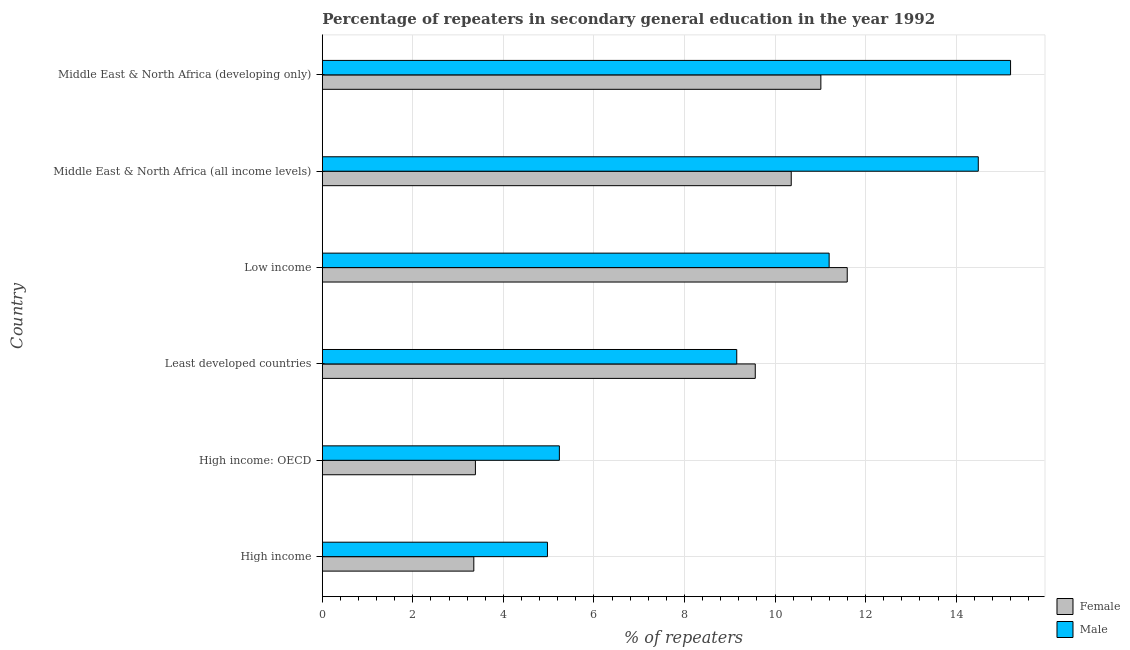How many bars are there on the 6th tick from the top?
Your answer should be very brief. 2. How many bars are there on the 6th tick from the bottom?
Provide a succinct answer. 2. What is the label of the 5th group of bars from the top?
Give a very brief answer. High income: OECD. What is the percentage of female repeaters in High income?
Your response must be concise. 3.35. Across all countries, what is the maximum percentage of female repeaters?
Your response must be concise. 11.59. Across all countries, what is the minimum percentage of female repeaters?
Provide a succinct answer. 3.35. In which country was the percentage of female repeaters maximum?
Provide a short and direct response. Low income. What is the total percentage of male repeaters in the graph?
Your answer should be compact. 60.25. What is the difference between the percentage of female repeaters in Least developed countries and that in Middle East & North Africa (developing only)?
Make the answer very short. -1.45. What is the difference between the percentage of female repeaters in High income and the percentage of male repeaters in High income: OECD?
Give a very brief answer. -1.89. What is the average percentage of male repeaters per country?
Keep it short and to the point. 10.04. What is the difference between the percentage of female repeaters and percentage of male repeaters in Middle East & North Africa (all income levels)?
Ensure brevity in your answer.  -4.13. In how many countries, is the percentage of male repeaters greater than 12 %?
Offer a very short reply. 2. What is the ratio of the percentage of female repeaters in High income: OECD to that in Least developed countries?
Provide a succinct answer. 0.35. Is the percentage of male repeaters in Least developed countries less than that in Middle East & North Africa (all income levels)?
Keep it short and to the point. Yes. What is the difference between the highest and the second highest percentage of female repeaters?
Give a very brief answer. 0.58. What is the difference between the highest and the lowest percentage of female repeaters?
Keep it short and to the point. 8.25. In how many countries, is the percentage of male repeaters greater than the average percentage of male repeaters taken over all countries?
Provide a succinct answer. 3. What does the 2nd bar from the bottom in Middle East & North Africa (all income levels) represents?
Ensure brevity in your answer.  Male. How many bars are there?
Offer a very short reply. 12. Are all the bars in the graph horizontal?
Your response must be concise. Yes. How many countries are there in the graph?
Your response must be concise. 6. What is the difference between two consecutive major ticks on the X-axis?
Offer a very short reply. 2. Are the values on the major ticks of X-axis written in scientific E-notation?
Offer a terse response. No. How many legend labels are there?
Offer a terse response. 2. What is the title of the graph?
Make the answer very short. Percentage of repeaters in secondary general education in the year 1992. Does "Under-5(male)" appear as one of the legend labels in the graph?
Provide a short and direct response. No. What is the label or title of the X-axis?
Offer a terse response. % of repeaters. What is the % of repeaters of Female in High income?
Keep it short and to the point. 3.35. What is the % of repeaters in Male in High income?
Ensure brevity in your answer.  4.97. What is the % of repeaters in Female in High income: OECD?
Provide a short and direct response. 3.38. What is the % of repeaters in Male in High income: OECD?
Your response must be concise. 5.24. What is the % of repeaters of Female in Least developed countries?
Provide a short and direct response. 9.56. What is the % of repeaters of Male in Least developed countries?
Your response must be concise. 9.15. What is the % of repeaters of Female in Low income?
Offer a very short reply. 11.59. What is the % of repeaters of Male in Low income?
Your answer should be very brief. 11.19. What is the % of repeaters of Female in Middle East & North Africa (all income levels)?
Offer a very short reply. 10.36. What is the % of repeaters of Male in Middle East & North Africa (all income levels)?
Make the answer very short. 14.49. What is the % of repeaters in Female in Middle East & North Africa (developing only)?
Give a very brief answer. 11.01. What is the % of repeaters in Male in Middle East & North Africa (developing only)?
Provide a succinct answer. 15.2. Across all countries, what is the maximum % of repeaters of Female?
Ensure brevity in your answer.  11.59. Across all countries, what is the maximum % of repeaters of Male?
Offer a very short reply. 15.2. Across all countries, what is the minimum % of repeaters of Female?
Give a very brief answer. 3.35. Across all countries, what is the minimum % of repeaters in Male?
Make the answer very short. 4.97. What is the total % of repeaters in Female in the graph?
Give a very brief answer. 49.25. What is the total % of repeaters in Male in the graph?
Make the answer very short. 60.25. What is the difference between the % of repeaters in Female in High income and that in High income: OECD?
Give a very brief answer. -0.04. What is the difference between the % of repeaters in Male in High income and that in High income: OECD?
Ensure brevity in your answer.  -0.26. What is the difference between the % of repeaters in Female in High income and that in Least developed countries?
Give a very brief answer. -6.22. What is the difference between the % of repeaters in Male in High income and that in Least developed countries?
Make the answer very short. -4.18. What is the difference between the % of repeaters of Female in High income and that in Low income?
Give a very brief answer. -8.25. What is the difference between the % of repeaters of Male in High income and that in Low income?
Provide a short and direct response. -6.22. What is the difference between the % of repeaters in Female in High income and that in Middle East & North Africa (all income levels)?
Keep it short and to the point. -7.01. What is the difference between the % of repeaters of Male in High income and that in Middle East & North Africa (all income levels)?
Your response must be concise. -9.52. What is the difference between the % of repeaters of Female in High income and that in Middle East & North Africa (developing only)?
Offer a terse response. -7.67. What is the difference between the % of repeaters of Male in High income and that in Middle East & North Africa (developing only)?
Your answer should be very brief. -10.23. What is the difference between the % of repeaters of Female in High income: OECD and that in Least developed countries?
Provide a succinct answer. -6.18. What is the difference between the % of repeaters of Male in High income: OECD and that in Least developed countries?
Give a very brief answer. -3.92. What is the difference between the % of repeaters of Female in High income: OECD and that in Low income?
Provide a succinct answer. -8.21. What is the difference between the % of repeaters in Male in High income: OECD and that in Low income?
Offer a very short reply. -5.96. What is the difference between the % of repeaters of Female in High income: OECD and that in Middle East & North Africa (all income levels)?
Give a very brief answer. -6.98. What is the difference between the % of repeaters in Male in High income: OECD and that in Middle East & North Africa (all income levels)?
Offer a very short reply. -9.25. What is the difference between the % of repeaters of Female in High income: OECD and that in Middle East & North Africa (developing only)?
Keep it short and to the point. -7.63. What is the difference between the % of repeaters in Male in High income: OECD and that in Middle East & North Africa (developing only)?
Offer a terse response. -9.97. What is the difference between the % of repeaters of Female in Least developed countries and that in Low income?
Provide a succinct answer. -2.03. What is the difference between the % of repeaters of Male in Least developed countries and that in Low income?
Your answer should be very brief. -2.04. What is the difference between the % of repeaters of Female in Least developed countries and that in Middle East & North Africa (all income levels)?
Offer a terse response. -0.79. What is the difference between the % of repeaters in Male in Least developed countries and that in Middle East & North Africa (all income levels)?
Offer a very short reply. -5.33. What is the difference between the % of repeaters of Female in Least developed countries and that in Middle East & North Africa (developing only)?
Your response must be concise. -1.45. What is the difference between the % of repeaters in Male in Least developed countries and that in Middle East & North Africa (developing only)?
Offer a terse response. -6.05. What is the difference between the % of repeaters in Female in Low income and that in Middle East & North Africa (all income levels)?
Offer a terse response. 1.24. What is the difference between the % of repeaters in Male in Low income and that in Middle East & North Africa (all income levels)?
Provide a succinct answer. -3.29. What is the difference between the % of repeaters in Female in Low income and that in Middle East & North Africa (developing only)?
Ensure brevity in your answer.  0.58. What is the difference between the % of repeaters of Male in Low income and that in Middle East & North Africa (developing only)?
Ensure brevity in your answer.  -4.01. What is the difference between the % of repeaters in Female in Middle East & North Africa (all income levels) and that in Middle East & North Africa (developing only)?
Make the answer very short. -0.65. What is the difference between the % of repeaters of Male in Middle East & North Africa (all income levels) and that in Middle East & North Africa (developing only)?
Your response must be concise. -0.71. What is the difference between the % of repeaters in Female in High income and the % of repeaters in Male in High income: OECD?
Keep it short and to the point. -1.89. What is the difference between the % of repeaters in Female in High income and the % of repeaters in Male in Least developed countries?
Ensure brevity in your answer.  -5.81. What is the difference between the % of repeaters in Female in High income and the % of repeaters in Male in Low income?
Provide a succinct answer. -7.85. What is the difference between the % of repeaters of Female in High income and the % of repeaters of Male in Middle East & North Africa (all income levels)?
Ensure brevity in your answer.  -11.14. What is the difference between the % of repeaters in Female in High income and the % of repeaters in Male in Middle East & North Africa (developing only)?
Keep it short and to the point. -11.86. What is the difference between the % of repeaters in Female in High income: OECD and the % of repeaters in Male in Least developed countries?
Offer a very short reply. -5.77. What is the difference between the % of repeaters in Female in High income: OECD and the % of repeaters in Male in Low income?
Offer a very short reply. -7.81. What is the difference between the % of repeaters in Female in High income: OECD and the % of repeaters in Male in Middle East & North Africa (all income levels)?
Keep it short and to the point. -11.11. What is the difference between the % of repeaters in Female in High income: OECD and the % of repeaters in Male in Middle East & North Africa (developing only)?
Offer a terse response. -11.82. What is the difference between the % of repeaters of Female in Least developed countries and the % of repeaters of Male in Low income?
Make the answer very short. -1.63. What is the difference between the % of repeaters in Female in Least developed countries and the % of repeaters in Male in Middle East & North Africa (all income levels)?
Your answer should be compact. -4.93. What is the difference between the % of repeaters in Female in Least developed countries and the % of repeaters in Male in Middle East & North Africa (developing only)?
Offer a terse response. -5.64. What is the difference between the % of repeaters in Female in Low income and the % of repeaters in Male in Middle East & North Africa (all income levels)?
Your response must be concise. -2.89. What is the difference between the % of repeaters of Female in Low income and the % of repeaters of Male in Middle East & North Africa (developing only)?
Make the answer very short. -3.61. What is the difference between the % of repeaters in Female in Middle East & North Africa (all income levels) and the % of repeaters in Male in Middle East & North Africa (developing only)?
Offer a very short reply. -4.84. What is the average % of repeaters in Female per country?
Your response must be concise. 8.21. What is the average % of repeaters of Male per country?
Offer a very short reply. 10.04. What is the difference between the % of repeaters of Female and % of repeaters of Male in High income?
Make the answer very short. -1.63. What is the difference between the % of repeaters of Female and % of repeaters of Male in High income: OECD?
Offer a terse response. -1.85. What is the difference between the % of repeaters in Female and % of repeaters in Male in Least developed countries?
Offer a terse response. 0.41. What is the difference between the % of repeaters of Female and % of repeaters of Male in Low income?
Give a very brief answer. 0.4. What is the difference between the % of repeaters in Female and % of repeaters in Male in Middle East & North Africa (all income levels)?
Ensure brevity in your answer.  -4.13. What is the difference between the % of repeaters in Female and % of repeaters in Male in Middle East & North Africa (developing only)?
Provide a short and direct response. -4.19. What is the ratio of the % of repeaters of Female in High income to that in High income: OECD?
Offer a terse response. 0.99. What is the ratio of the % of repeaters in Male in High income to that in High income: OECD?
Provide a succinct answer. 0.95. What is the ratio of the % of repeaters of Female in High income to that in Least developed countries?
Keep it short and to the point. 0.35. What is the ratio of the % of repeaters in Male in High income to that in Least developed countries?
Provide a succinct answer. 0.54. What is the ratio of the % of repeaters in Female in High income to that in Low income?
Provide a short and direct response. 0.29. What is the ratio of the % of repeaters of Male in High income to that in Low income?
Your answer should be very brief. 0.44. What is the ratio of the % of repeaters in Female in High income to that in Middle East & North Africa (all income levels)?
Offer a terse response. 0.32. What is the ratio of the % of repeaters in Male in High income to that in Middle East & North Africa (all income levels)?
Offer a very short reply. 0.34. What is the ratio of the % of repeaters of Female in High income to that in Middle East & North Africa (developing only)?
Make the answer very short. 0.3. What is the ratio of the % of repeaters in Male in High income to that in Middle East & North Africa (developing only)?
Your response must be concise. 0.33. What is the ratio of the % of repeaters in Female in High income: OECD to that in Least developed countries?
Offer a very short reply. 0.35. What is the ratio of the % of repeaters of Male in High income: OECD to that in Least developed countries?
Ensure brevity in your answer.  0.57. What is the ratio of the % of repeaters of Female in High income: OECD to that in Low income?
Provide a succinct answer. 0.29. What is the ratio of the % of repeaters of Male in High income: OECD to that in Low income?
Make the answer very short. 0.47. What is the ratio of the % of repeaters in Female in High income: OECD to that in Middle East & North Africa (all income levels)?
Give a very brief answer. 0.33. What is the ratio of the % of repeaters of Male in High income: OECD to that in Middle East & North Africa (all income levels)?
Make the answer very short. 0.36. What is the ratio of the % of repeaters in Female in High income: OECD to that in Middle East & North Africa (developing only)?
Provide a succinct answer. 0.31. What is the ratio of the % of repeaters of Male in High income: OECD to that in Middle East & North Africa (developing only)?
Offer a terse response. 0.34. What is the ratio of the % of repeaters in Female in Least developed countries to that in Low income?
Provide a succinct answer. 0.82. What is the ratio of the % of repeaters of Male in Least developed countries to that in Low income?
Make the answer very short. 0.82. What is the ratio of the % of repeaters of Female in Least developed countries to that in Middle East & North Africa (all income levels)?
Your answer should be very brief. 0.92. What is the ratio of the % of repeaters in Male in Least developed countries to that in Middle East & North Africa (all income levels)?
Provide a short and direct response. 0.63. What is the ratio of the % of repeaters in Female in Least developed countries to that in Middle East & North Africa (developing only)?
Give a very brief answer. 0.87. What is the ratio of the % of repeaters in Male in Least developed countries to that in Middle East & North Africa (developing only)?
Give a very brief answer. 0.6. What is the ratio of the % of repeaters of Female in Low income to that in Middle East & North Africa (all income levels)?
Give a very brief answer. 1.12. What is the ratio of the % of repeaters of Male in Low income to that in Middle East & North Africa (all income levels)?
Give a very brief answer. 0.77. What is the ratio of the % of repeaters of Female in Low income to that in Middle East & North Africa (developing only)?
Offer a very short reply. 1.05. What is the ratio of the % of repeaters of Male in Low income to that in Middle East & North Africa (developing only)?
Provide a succinct answer. 0.74. What is the ratio of the % of repeaters of Female in Middle East & North Africa (all income levels) to that in Middle East & North Africa (developing only)?
Provide a short and direct response. 0.94. What is the ratio of the % of repeaters of Male in Middle East & North Africa (all income levels) to that in Middle East & North Africa (developing only)?
Your response must be concise. 0.95. What is the difference between the highest and the second highest % of repeaters in Female?
Your answer should be very brief. 0.58. What is the difference between the highest and the second highest % of repeaters in Male?
Offer a terse response. 0.71. What is the difference between the highest and the lowest % of repeaters in Female?
Offer a very short reply. 8.25. What is the difference between the highest and the lowest % of repeaters in Male?
Ensure brevity in your answer.  10.23. 